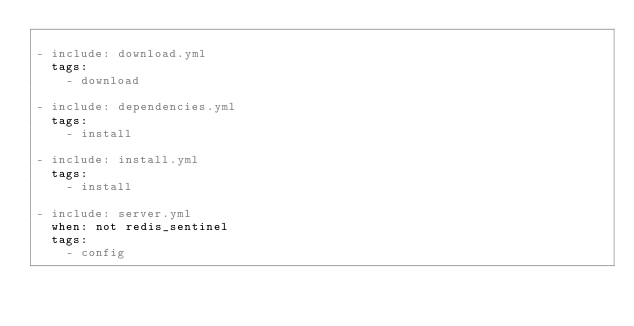<code> <loc_0><loc_0><loc_500><loc_500><_YAML_>
- include: download.yml
  tags:
    - download

- include: dependencies.yml
  tags:
    - install

- include: install.yml
  tags:
    - install

- include: server.yml
  when: not redis_sentinel
  tags:
    - config
</code> 